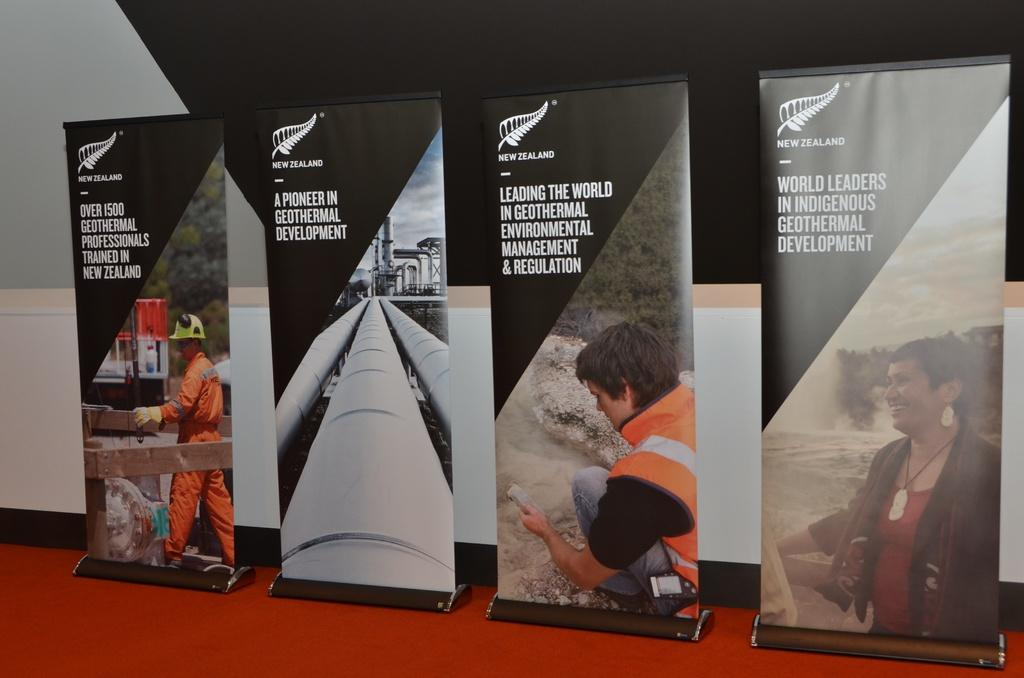<image>
Summarize the visual content of the image. Four signs with information about the New Zealand scientists 